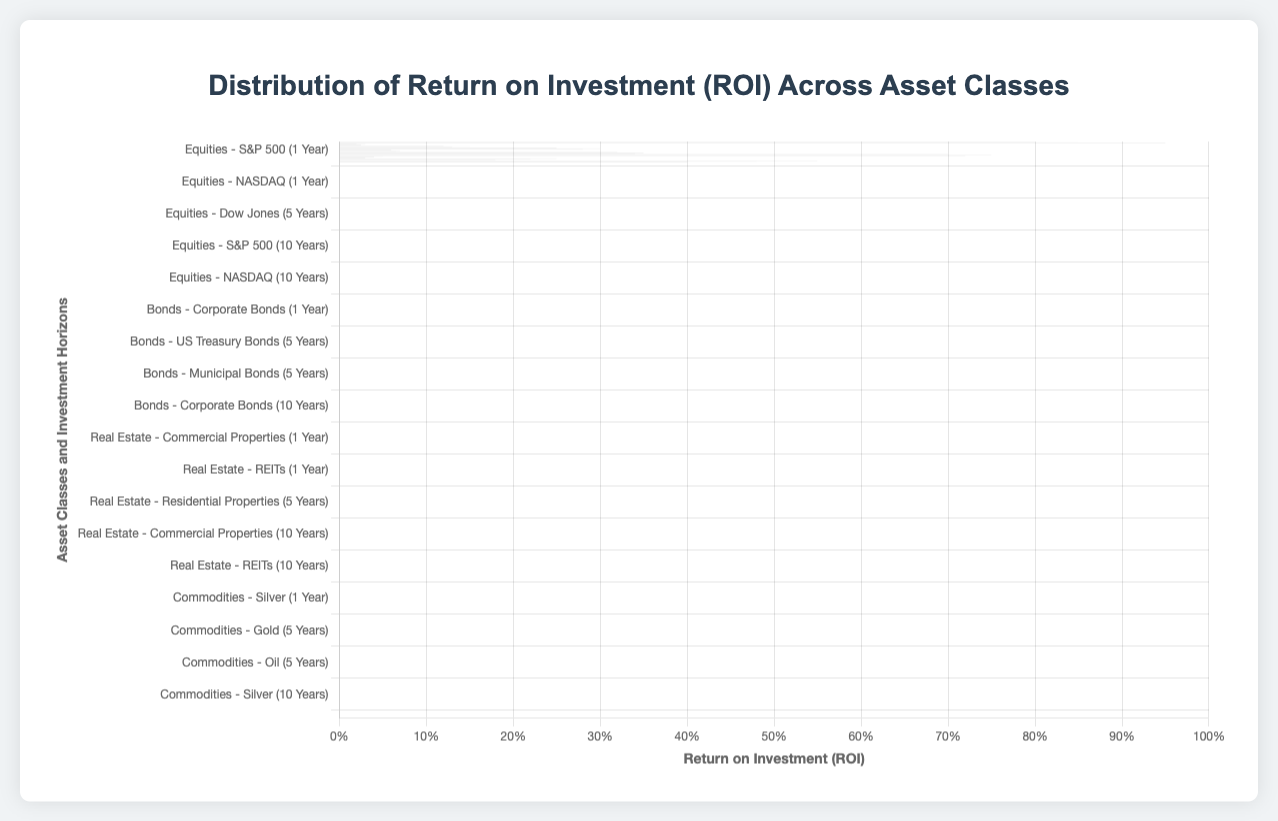Which asset class has the highest ROI for a 10-year investment horizon? The asset class with the highest ROI for a 10-year investment horizon is Equities (NASDAQ) with an ROI of 0.95.
Answer: Equities (NASDAQ) Which entity within the Bonds asset class has the highest ROI for a 5-year horizon, and how does it compare to the entity with the lowest ROI within the same asset class and horizon? The highest ROI in Bonds for a 5-year horizon is Corporate Bonds with an ROI of 0.15, and the lowest is Municipal Bonds with an ROI of 0.13. The difference between the highest and lowest ROIs is 0.15 - 0.13 = 0.02.
Answer: Corporate Bonds, 0.02 What is the average ROI for Real Estate across all investment horizons? Calculate the average of the ROIs for Commercial Properties, Residential Properties, and REITs across 1 year, 5 years, and 10 years. (0.06 + 0.07 + 0.065 + 0.32 + 0.35 + 0.34 + 0.70 + 0.75 + 0.72) / 9 ≈ 0.376.
Answer: 0.376 Which entity in the Commodities asset class has a higher ROI, Gold or Silver, for a 1-year investment horizon, and by how much? For a 1-year horizon, Gold has an ROI of 0.05 and Silver has an ROI of 0.04. The difference is 0.05 - 0.04 = 0.01.
Answer: Gold, 0.01 Between the Equities and Bonds asset classes, which has a higher average ROI for a 1-year horizon? Calculate the average ROI for each asset class for a 1-year horizon: Equities: (0.08 + 0.07 + 0.09) / 3 = 0.08, Bonds: (0.02 + 0.03 + 0.025) / 3 ≈ 0.025. The Equities class has a higher average ROI (0.08) compared to Bonds (0.025).
Answer: Equities What is the total ROI of all entities in the Real Estate asset class for a 10-year horizon? Sum the ROIs of Commercial Properties, Residential Properties, and REITs for a 10-year horizon: 0.70 + 0.75 + 0.72 = 2.17.
Answer: 2.17 In the Equities asset class, which entity shows the greatest increase in ROI from a 1-year to a 10-year investment horizon? Calculate the increase for each entity: S&P 500: 0.85 - 0.08 = 0.77, Dow Jones: 0.80 - 0.07 = 0.73, NASDAQ: 0.95 - 0.09 = 0.86. NASDAQ shows the greatest increase, 0.86.
Answer: NASDAQ In the Bonds asset class, which investment horizon shows the highest variation in ROI among its entities? Calculate the variance for each horizon: 1 Year: max - min = 0.03 - 0.02 = 0.01, 5 Years: 0.15 - 0.12 = 0.03, 10 Years: 0.30 - 0.25 = 0.05. The 10-year horizon shows the highest variation.
Answer: 10 Years Compare the visual lengths of the bars representing the ROI of Equities (S&P 500) for 1-year and 10-year horizons. The bar for the 10-year horizon (0.85) is visually much longer than the bar for the 1-year horizon (0.08).
Answer: 10-year horizon is longer 